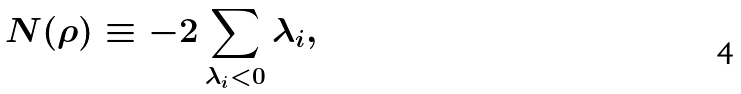<formula> <loc_0><loc_0><loc_500><loc_500>N ( \rho ) \equiv - 2 \sum _ { \lambda _ { i } < 0 } \lambda _ { i } ,</formula> 